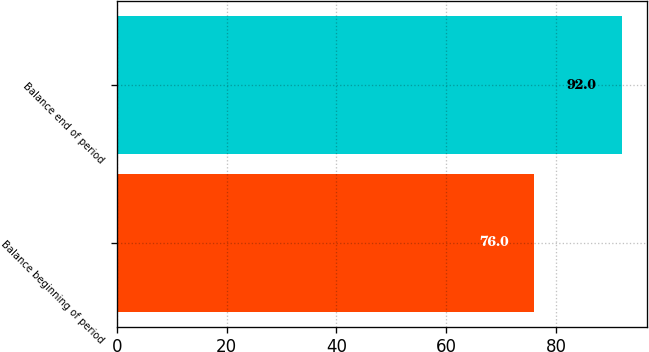Convert chart to OTSL. <chart><loc_0><loc_0><loc_500><loc_500><bar_chart><fcel>Balance beginning of period<fcel>Balance end of period<nl><fcel>76<fcel>92<nl></chart> 